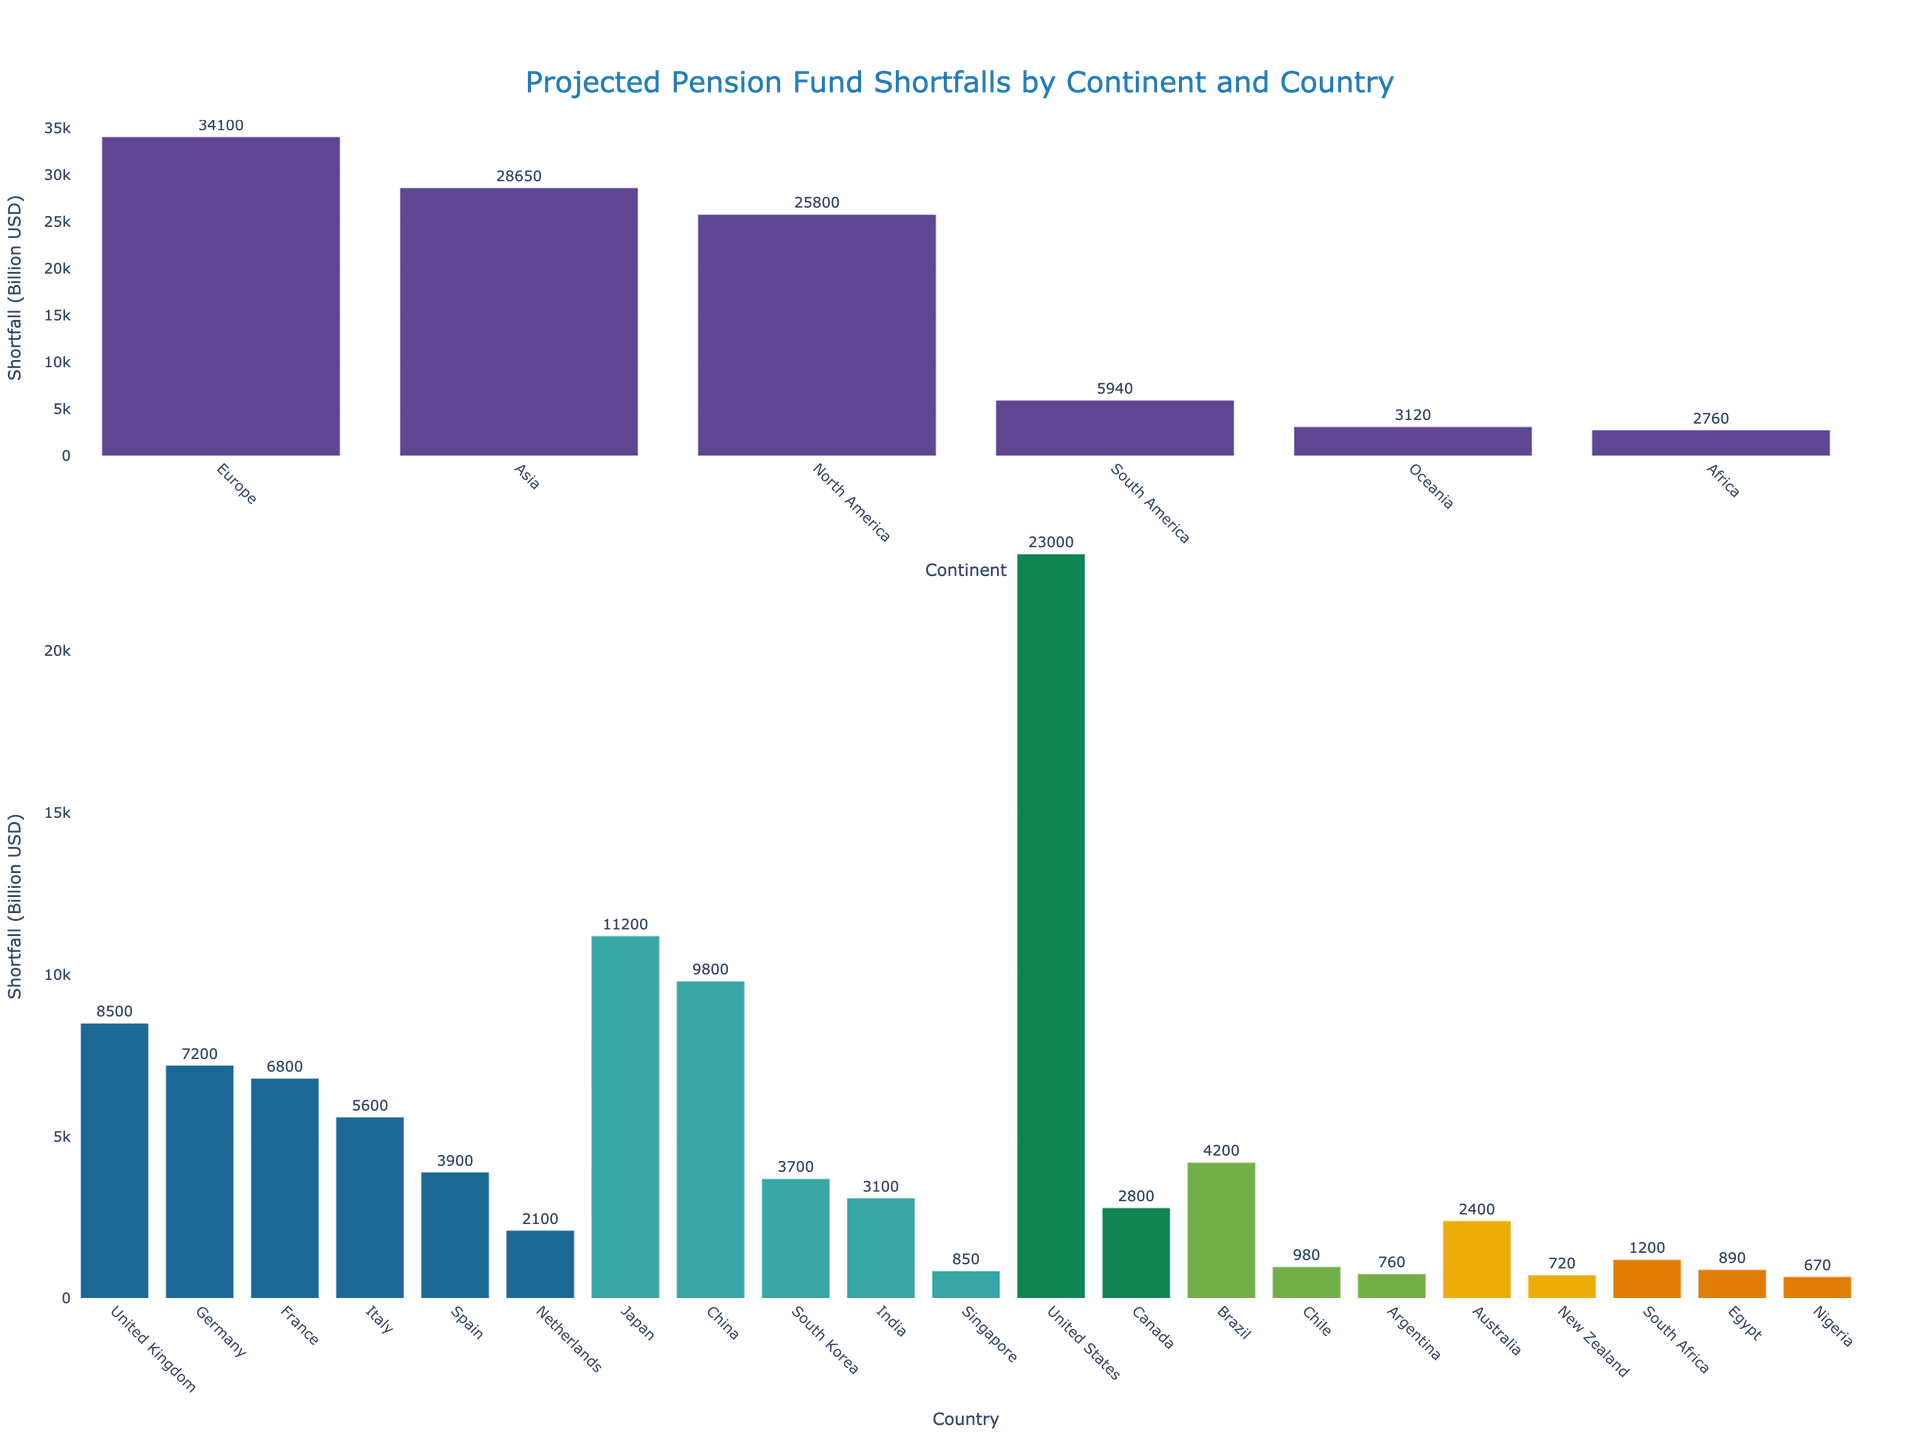Which continent has the highest projected pension fund shortfall? Examine the bar for each continent in the top part of the figure, noting that North America has the largest bar.
Answer: North America Which country in Europe has the largest projected pension fund shortfall? Look at the bars representing European countries in the second row of the figure; the United Kingdom has the largest bar.
Answer: United Kingdom What is the approximate difference between the projected pension fund shortfall for the United States and China? Note the projected shortfall for the United States (23,000 billion USD) and China (9,800 billion USD) and subtract China’s from the United States.
Answer: 13,200 billion USD Which continent has the least projected pension fund shortfall? Compare the heights of the bars representing each continent, noting that Africa has the smallest bar.
Answer: Africa What is the combined projected pension fund shortfall for South America? Add the values of the projected shortfalls for Brazil (4,200 billion USD), Chile (980 billion USD), and Argentina (760 billion USD).
Answer: 5,940 billion USD Is the projected pension fund shortfall for Germany greater than that for Japan? Observe the individual bars for Germany and Japan in their respective sections, noting that Japan’s bar is higher than Germany’s.
Answer: No What is the total projected pension fund shortfall for countries in Oceania? Sum the values of the projected shortfalls for Australia (2,400 billion USD) and New Zealand (720 billion USD).
Answer: 3,120 billion USD How does the projected pension fund shortfall for South Korea compare to that for Spain? Compare the lengths of the bars for South Korea and Spain, noting that Spain’s is slightly longer.
Answer: Spain is higher What is the visual attribute used to distinguish between different continents and countries in the figure? Identify that different colors are used for bars representing countries from different continents in the figure.
Answer: Colors What is the average projected pension fund shortfall for the countries in Asia? Sum the shortfalls of the Asian countries (Japan 11,200 + China 9,800 + South Korea 3,700 + India 3,100 + Singapore 850), then divide by 5.
Answer: 5,730 billion USD 